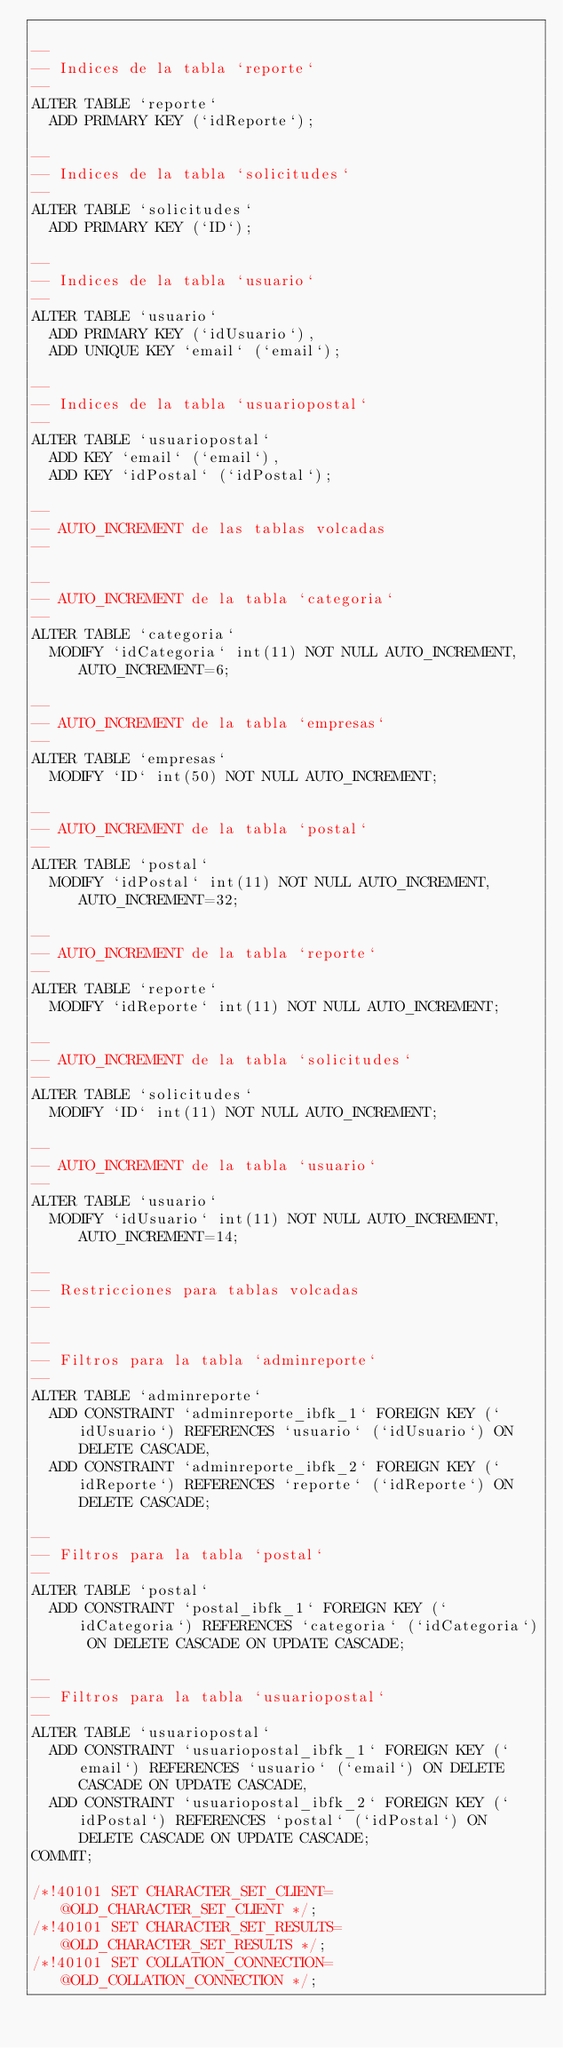Convert code to text. <code><loc_0><loc_0><loc_500><loc_500><_SQL_>
--
-- Indices de la tabla `reporte`
--
ALTER TABLE `reporte`
  ADD PRIMARY KEY (`idReporte`);

--
-- Indices de la tabla `solicitudes`
--
ALTER TABLE `solicitudes`
  ADD PRIMARY KEY (`ID`);

--
-- Indices de la tabla `usuario`
--
ALTER TABLE `usuario`
  ADD PRIMARY KEY (`idUsuario`),
  ADD UNIQUE KEY `email` (`email`);

--
-- Indices de la tabla `usuariopostal`
--
ALTER TABLE `usuariopostal`
  ADD KEY `email` (`email`),
  ADD KEY `idPostal` (`idPostal`);

--
-- AUTO_INCREMENT de las tablas volcadas
--

--
-- AUTO_INCREMENT de la tabla `categoria`
--
ALTER TABLE `categoria`
  MODIFY `idCategoria` int(11) NOT NULL AUTO_INCREMENT, AUTO_INCREMENT=6;

--
-- AUTO_INCREMENT de la tabla `empresas`
--
ALTER TABLE `empresas`
  MODIFY `ID` int(50) NOT NULL AUTO_INCREMENT;

--
-- AUTO_INCREMENT de la tabla `postal`
--
ALTER TABLE `postal`
  MODIFY `idPostal` int(11) NOT NULL AUTO_INCREMENT, AUTO_INCREMENT=32;

--
-- AUTO_INCREMENT de la tabla `reporte`
--
ALTER TABLE `reporte`
  MODIFY `idReporte` int(11) NOT NULL AUTO_INCREMENT;

--
-- AUTO_INCREMENT de la tabla `solicitudes`
--
ALTER TABLE `solicitudes`
  MODIFY `ID` int(11) NOT NULL AUTO_INCREMENT;

--
-- AUTO_INCREMENT de la tabla `usuario`
--
ALTER TABLE `usuario`
  MODIFY `idUsuario` int(11) NOT NULL AUTO_INCREMENT, AUTO_INCREMENT=14;

--
-- Restricciones para tablas volcadas
--

--
-- Filtros para la tabla `adminreporte`
--
ALTER TABLE `adminreporte`
  ADD CONSTRAINT `adminreporte_ibfk_1` FOREIGN KEY (`idUsuario`) REFERENCES `usuario` (`idUsuario`) ON DELETE CASCADE,
  ADD CONSTRAINT `adminreporte_ibfk_2` FOREIGN KEY (`idReporte`) REFERENCES `reporte` (`idReporte`) ON DELETE CASCADE;

--
-- Filtros para la tabla `postal`
--
ALTER TABLE `postal`
  ADD CONSTRAINT `postal_ibfk_1` FOREIGN KEY (`idCategoria`) REFERENCES `categoria` (`idCategoria`) ON DELETE CASCADE ON UPDATE CASCADE;

--
-- Filtros para la tabla `usuariopostal`
--
ALTER TABLE `usuariopostal`
  ADD CONSTRAINT `usuariopostal_ibfk_1` FOREIGN KEY (`email`) REFERENCES `usuario` (`email`) ON DELETE CASCADE ON UPDATE CASCADE,
  ADD CONSTRAINT `usuariopostal_ibfk_2` FOREIGN KEY (`idPostal`) REFERENCES `postal` (`idPostal`) ON DELETE CASCADE ON UPDATE CASCADE;
COMMIT;

/*!40101 SET CHARACTER_SET_CLIENT=@OLD_CHARACTER_SET_CLIENT */;
/*!40101 SET CHARACTER_SET_RESULTS=@OLD_CHARACTER_SET_RESULTS */;
/*!40101 SET COLLATION_CONNECTION=@OLD_COLLATION_CONNECTION */;
</code> 